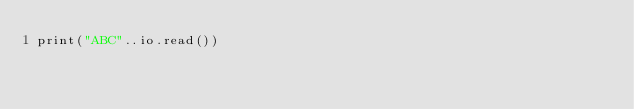<code> <loc_0><loc_0><loc_500><loc_500><_Lua_>print("ABC"..io.read())</code> 